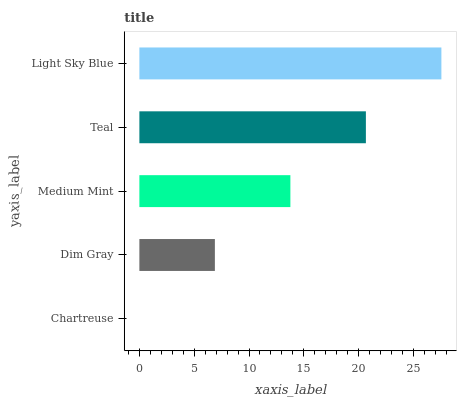Is Chartreuse the minimum?
Answer yes or no. Yes. Is Light Sky Blue the maximum?
Answer yes or no. Yes. Is Dim Gray the minimum?
Answer yes or no. No. Is Dim Gray the maximum?
Answer yes or no. No. Is Dim Gray greater than Chartreuse?
Answer yes or no. Yes. Is Chartreuse less than Dim Gray?
Answer yes or no. Yes. Is Chartreuse greater than Dim Gray?
Answer yes or no. No. Is Dim Gray less than Chartreuse?
Answer yes or no. No. Is Medium Mint the high median?
Answer yes or no. Yes. Is Medium Mint the low median?
Answer yes or no. Yes. Is Chartreuse the high median?
Answer yes or no. No. Is Chartreuse the low median?
Answer yes or no. No. 